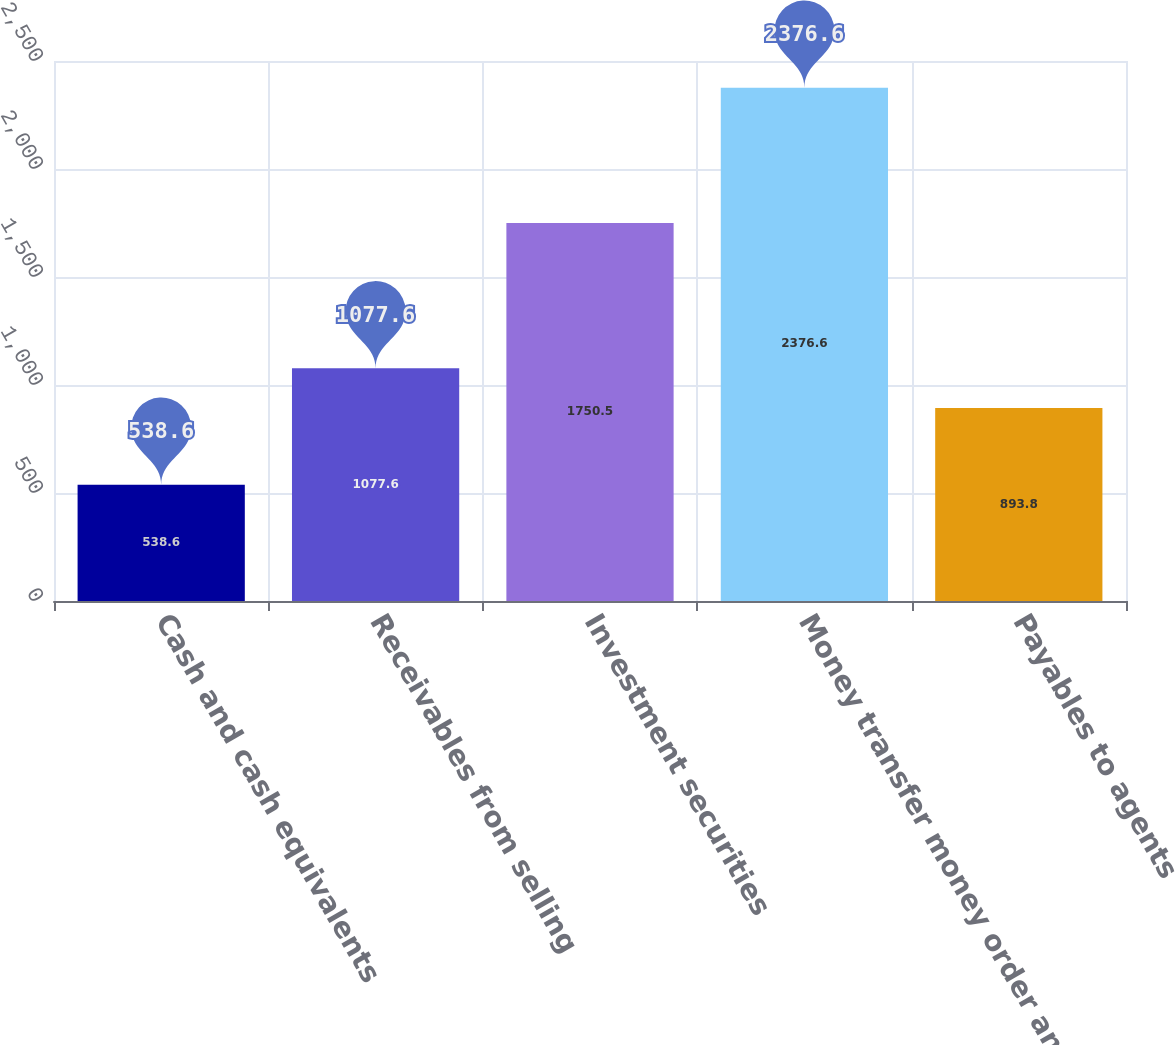<chart> <loc_0><loc_0><loc_500><loc_500><bar_chart><fcel>Cash and cash equivalents<fcel>Receivables from selling<fcel>Investment securities<fcel>Money transfer money order and<fcel>Payables to agents<nl><fcel>538.6<fcel>1077.6<fcel>1750.5<fcel>2376.6<fcel>893.8<nl></chart> 